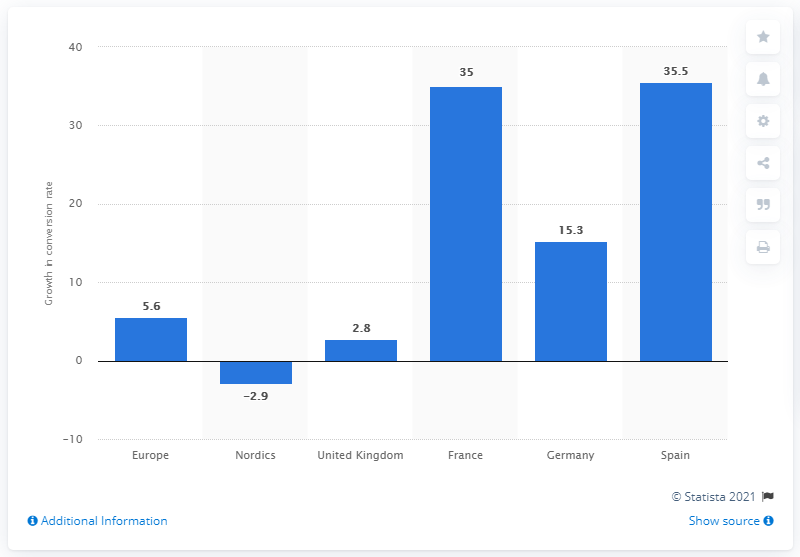Indicate a few pertinent items in this graphic. In 2015 and 2016, Spain's web conversion rate was 35.5%. 